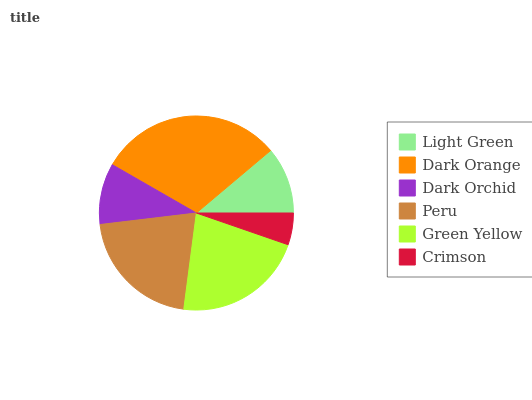Is Crimson the minimum?
Answer yes or no. Yes. Is Dark Orange the maximum?
Answer yes or no. Yes. Is Dark Orchid the minimum?
Answer yes or no. No. Is Dark Orchid the maximum?
Answer yes or no. No. Is Dark Orange greater than Dark Orchid?
Answer yes or no. Yes. Is Dark Orchid less than Dark Orange?
Answer yes or no. Yes. Is Dark Orchid greater than Dark Orange?
Answer yes or no. No. Is Dark Orange less than Dark Orchid?
Answer yes or no. No. Is Peru the high median?
Answer yes or no. Yes. Is Light Green the low median?
Answer yes or no. Yes. Is Dark Orchid the high median?
Answer yes or no. No. Is Crimson the low median?
Answer yes or no. No. 